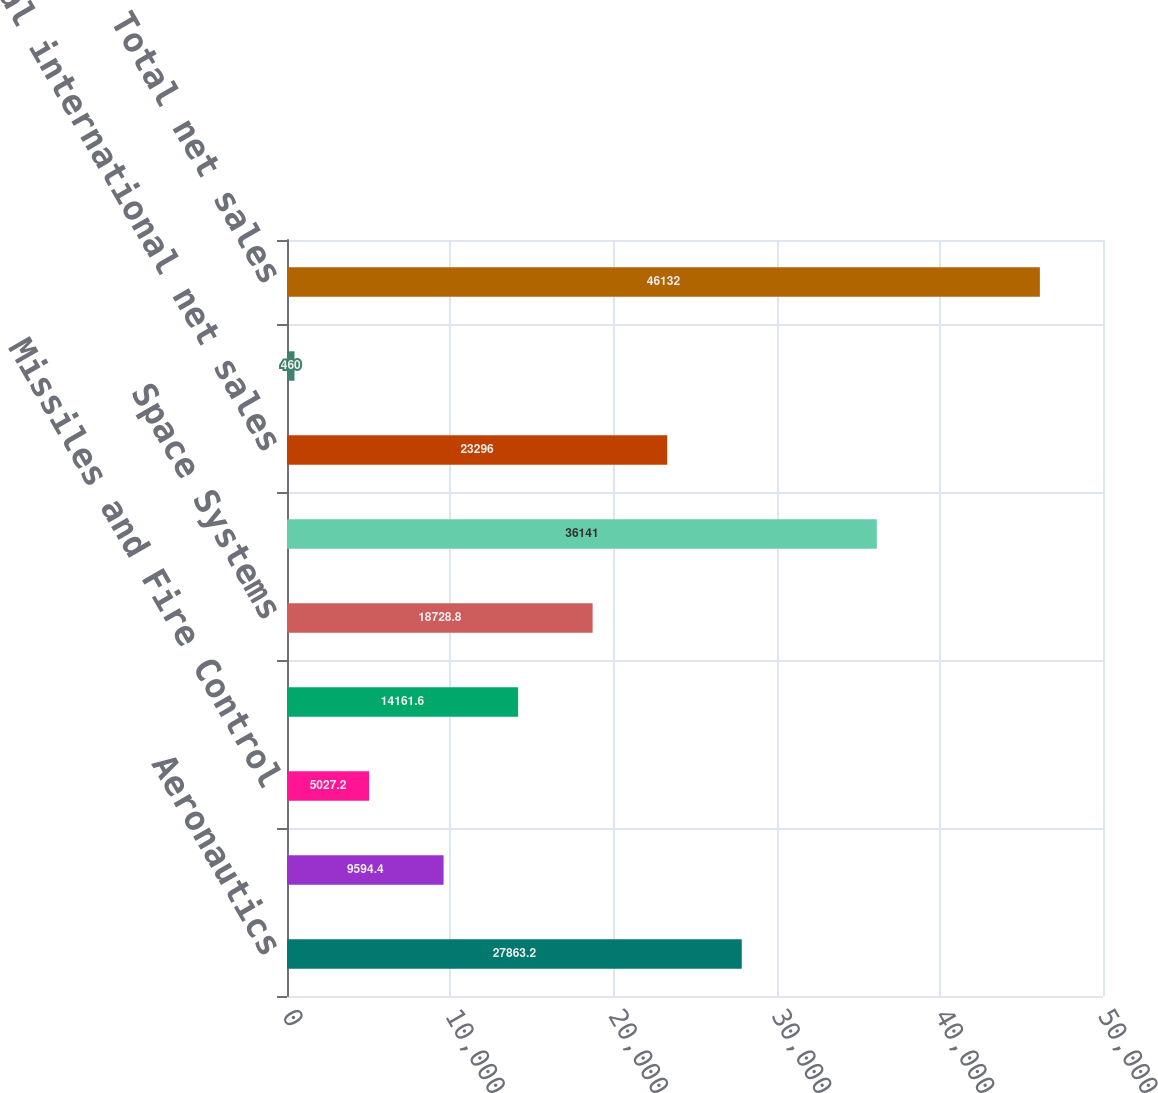Convert chart. <chart><loc_0><loc_0><loc_500><loc_500><bar_chart><fcel>Aeronautics<fcel>Information Systems & Global<fcel>Missiles and Fire Control<fcel>Mission Systems and Training<fcel>Space Systems<fcel>Total US Government net sales<fcel>Total international net sales<fcel>Total US commercial and other<fcel>Total net sales<nl><fcel>27863.2<fcel>9594.4<fcel>5027.2<fcel>14161.6<fcel>18728.8<fcel>36141<fcel>23296<fcel>460<fcel>46132<nl></chart> 